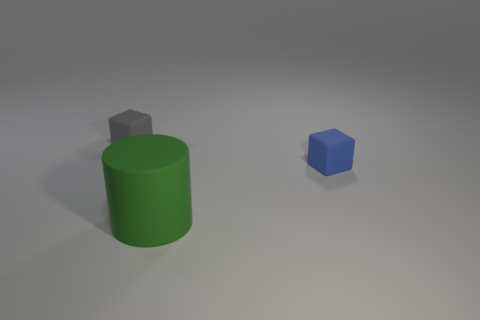Subtract all cylinders. How many objects are left? 2 Subtract 1 cylinders. How many cylinders are left? 0 Subtract 0 purple cubes. How many objects are left? 3 Subtract all red blocks. Subtract all green balls. How many blocks are left? 2 Subtract all red blocks. How many cyan cylinders are left? 0 Subtract all big shiny balls. Subtract all blue objects. How many objects are left? 2 Add 3 cylinders. How many cylinders are left? 4 Add 3 large matte cylinders. How many large matte cylinders exist? 4 Add 1 red rubber balls. How many objects exist? 4 Subtract all gray cubes. How many cubes are left? 1 